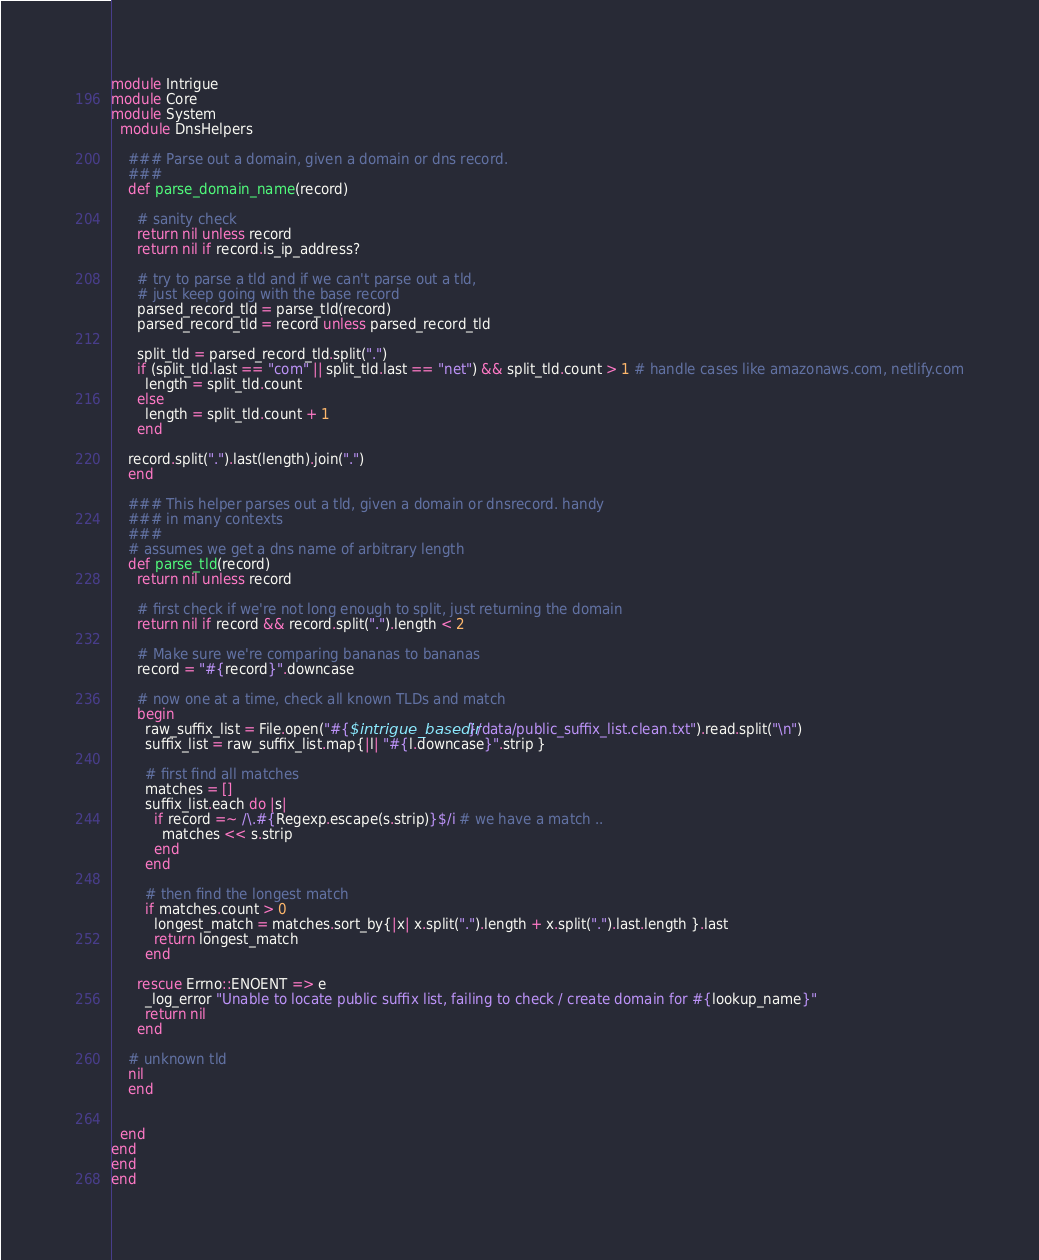<code> <loc_0><loc_0><loc_500><loc_500><_Ruby_>module Intrigue
module Core
module System
  module DnsHelpers

    ### Parse out a domain, given a domain or dns record.
    ###
    def parse_domain_name(record)

      # sanity check
      return nil unless record 
      return nil if record.is_ip_address?

      # try to parse a tld and if we can't parse out a tld, 
      # just keep going with the base record
      parsed_record_tld = parse_tld(record)
      parsed_record_tld = record unless parsed_record_tld 

      split_tld = parsed_record_tld.split(".")
      if (split_tld.last == "com" || split_tld.last == "net") && split_tld.count > 1 # handle cases like amazonaws.com, netlify.com
        length = split_tld.count
      else
        length = split_tld.count + 1
      end
      
    record.split(".").last(length).join(".")
    end

    ### This helper parses out a tld, given a domain or dnsrecord. handy
    ### in many contexts 
    ###
    # assumes we get a dns name of arbitrary length
    def parse_tld(record)
      return nil unless record

      # first check if we're not long enough to split, just returning the domain
      return nil if record && record.split(".").length < 2

      # Make sure we're comparing bananas to bananas
      record = "#{record}".downcase

      # now one at a time, check all known TLDs and match
      begin
        raw_suffix_list = File.open("#{$intrigue_basedir}/data/public_suffix_list.clean.txt").read.split("\n")
        suffix_list = raw_suffix_list.map{|l| "#{l.downcase}".strip }

        # first find all matches
        matches = []
        suffix_list.each do |s|
          if record =~ /\.#{Regexp.escape(s.strip)}$/i # we have a match ..
            matches << s.strip
          end
        end

        # then find the longest match
        if matches.count > 0
          longest_match = matches.sort_by{|x| x.split(".").length + x.split(".").last.length }.last
          return longest_match
        end

      rescue Errno::ENOENT => e
        _log_error "Unable to locate public suffix list, failing to check / create domain for #{lookup_name}"
        return nil
      end

    # unknown tld
    nil
    end


  end
end
end
end</code> 